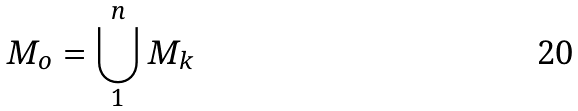<formula> <loc_0><loc_0><loc_500><loc_500>M _ { o } = \bigcup _ { 1 } ^ { n } M _ { k }</formula> 